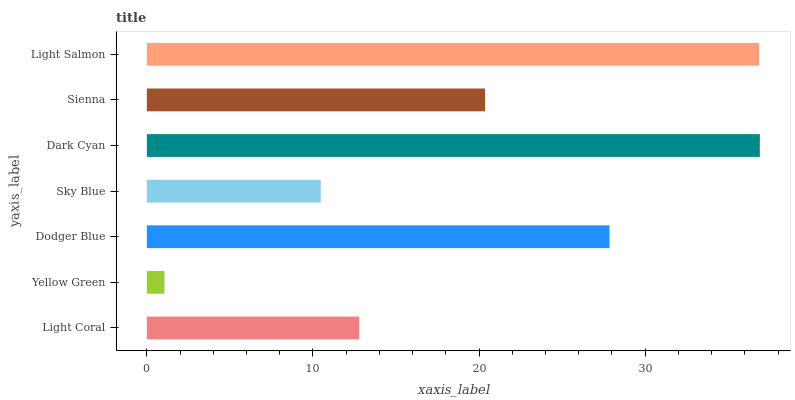Is Yellow Green the minimum?
Answer yes or no. Yes. Is Dark Cyan the maximum?
Answer yes or no. Yes. Is Dodger Blue the minimum?
Answer yes or no. No. Is Dodger Blue the maximum?
Answer yes or no. No. Is Dodger Blue greater than Yellow Green?
Answer yes or no. Yes. Is Yellow Green less than Dodger Blue?
Answer yes or no. Yes. Is Yellow Green greater than Dodger Blue?
Answer yes or no. No. Is Dodger Blue less than Yellow Green?
Answer yes or no. No. Is Sienna the high median?
Answer yes or no. Yes. Is Sienna the low median?
Answer yes or no. Yes. Is Dark Cyan the high median?
Answer yes or no. No. Is Light Coral the low median?
Answer yes or no. No. 